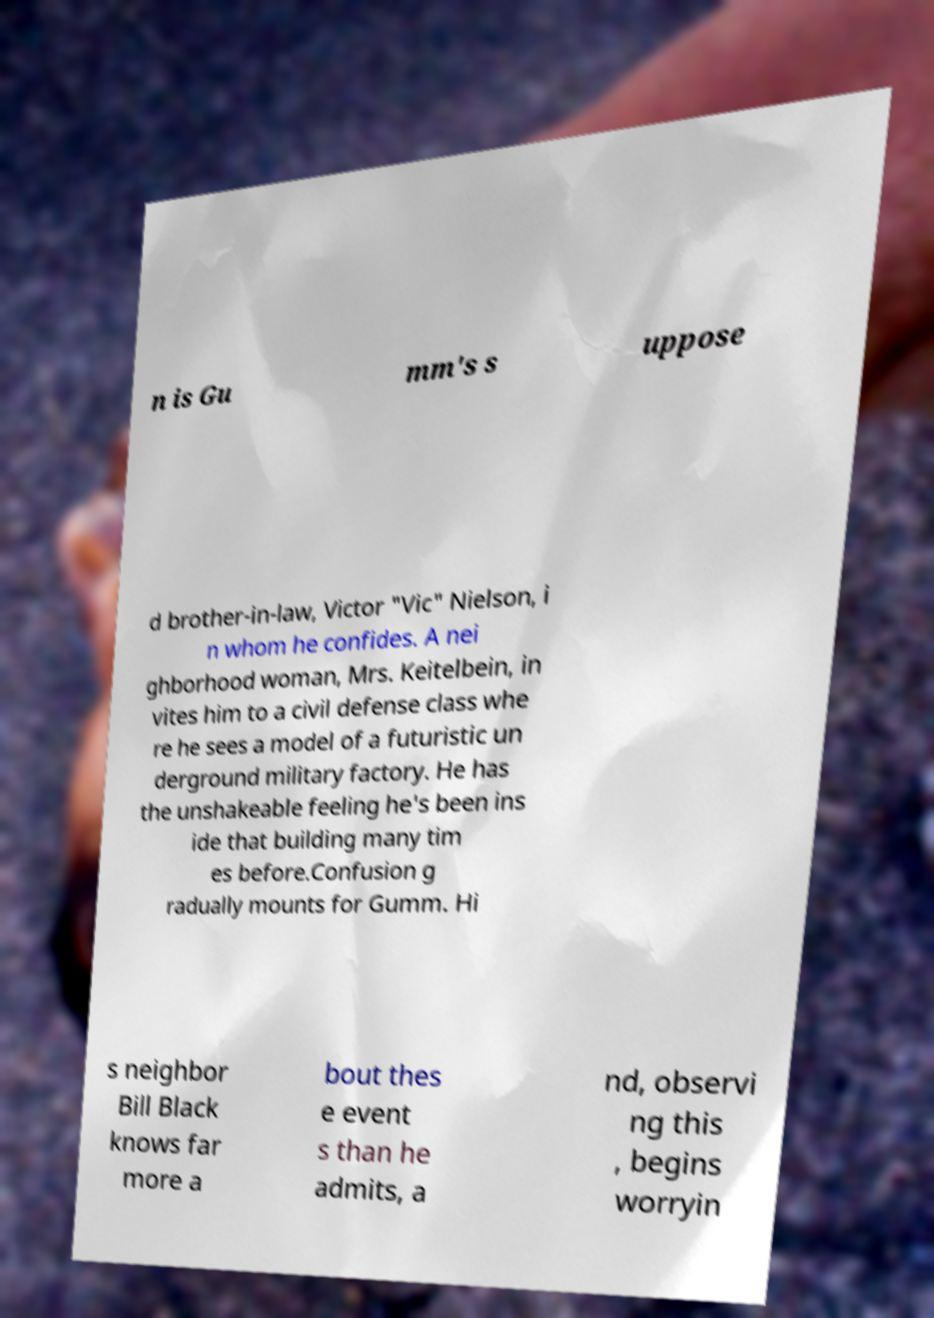Please identify and transcribe the text found in this image. n is Gu mm's s uppose d brother-in-law, Victor "Vic" Nielson, i n whom he confides. A nei ghborhood woman, Mrs. Keitelbein, in vites him to a civil defense class whe re he sees a model of a futuristic un derground military factory. He has the unshakeable feeling he's been ins ide that building many tim es before.Confusion g radually mounts for Gumm. Hi s neighbor Bill Black knows far more a bout thes e event s than he admits, a nd, observi ng this , begins worryin 